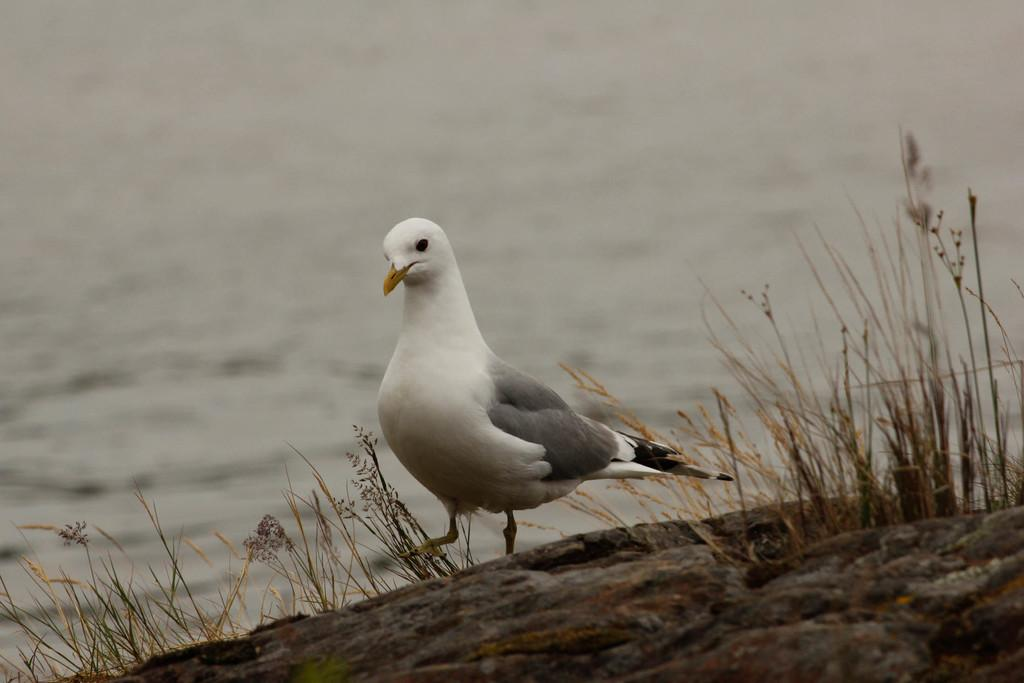What type of animal is in the image? There is a white color bird in the image. Where is the bird located? The bird is on a rock. What type of vegetation can be seen in the image? There is grass visible in the image. What can be seen in the background of the image? There is water visible in the background of the image. What type of record can be seen in the image? There is no record present in the image. Is there a brick wall visible in the image? There is no brick wall visible in the image. 